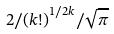<formula> <loc_0><loc_0><loc_500><loc_500>2 / { ( k ! ) } ^ { 1 / 2 k } / \sqrt { \pi }</formula> 